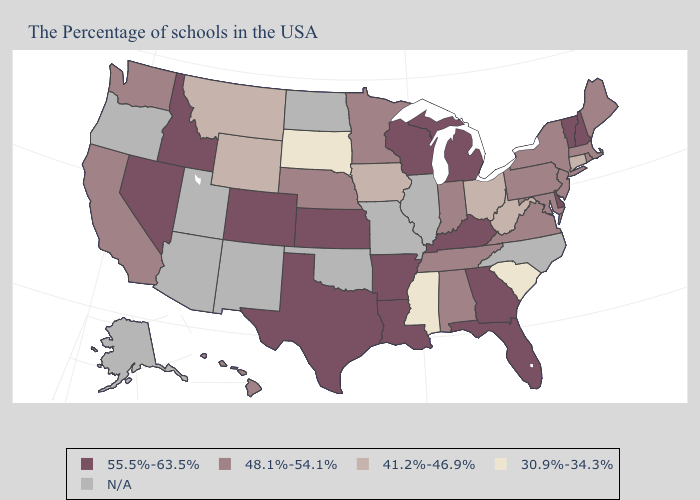Does the first symbol in the legend represent the smallest category?
Be succinct. No. How many symbols are there in the legend?
Quick response, please. 5. Name the states that have a value in the range 41.2%-46.9%?
Quick response, please. Connecticut, West Virginia, Ohio, Iowa, Wyoming, Montana. Which states hav the highest value in the South?
Concise answer only. Delaware, Florida, Georgia, Kentucky, Louisiana, Arkansas, Texas. What is the lowest value in the South?
Short answer required. 30.9%-34.3%. What is the lowest value in the USA?
Quick response, please. 30.9%-34.3%. Does West Virginia have the highest value in the South?
Keep it brief. No. Which states have the lowest value in the USA?
Write a very short answer. South Carolina, Mississippi, South Dakota. Which states hav the highest value in the Northeast?
Give a very brief answer. New Hampshire, Vermont. Which states hav the highest value in the Northeast?
Concise answer only. New Hampshire, Vermont. Does Michigan have the lowest value in the MidWest?
Give a very brief answer. No. What is the value of Virginia?
Concise answer only. 48.1%-54.1%. What is the value of Alabama?
Be succinct. 48.1%-54.1%. What is the value of Massachusetts?
Concise answer only. 48.1%-54.1%. 